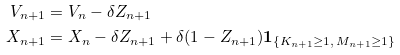<formula> <loc_0><loc_0><loc_500><loc_500>V _ { n + 1 } & = V _ { n } - \delta Z _ { n + 1 } \\ X _ { n + 1 } & = X _ { n } - \delta Z _ { n + 1 } + \delta ( 1 - Z _ { n + 1 } ) { \mathbf 1 } _ { \{ K _ { n + 1 } \geq 1 , \, M _ { n + 1 } \geq 1 \} }</formula> 